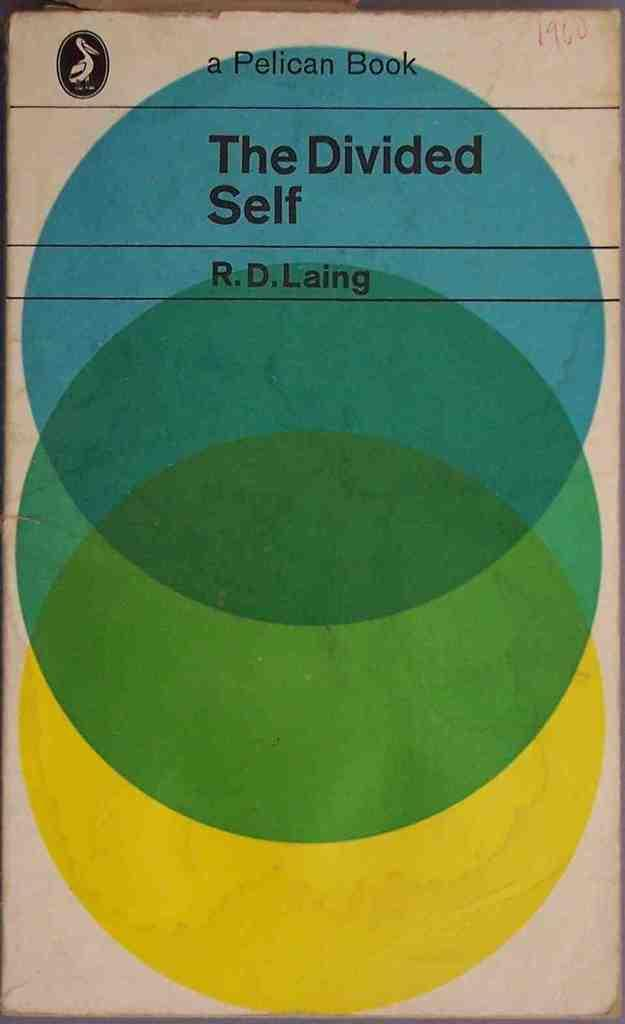Provide a one-sentence caption for the provided image. Book titled The Divided Self by R.D. Laing that shows three different colored circles. 